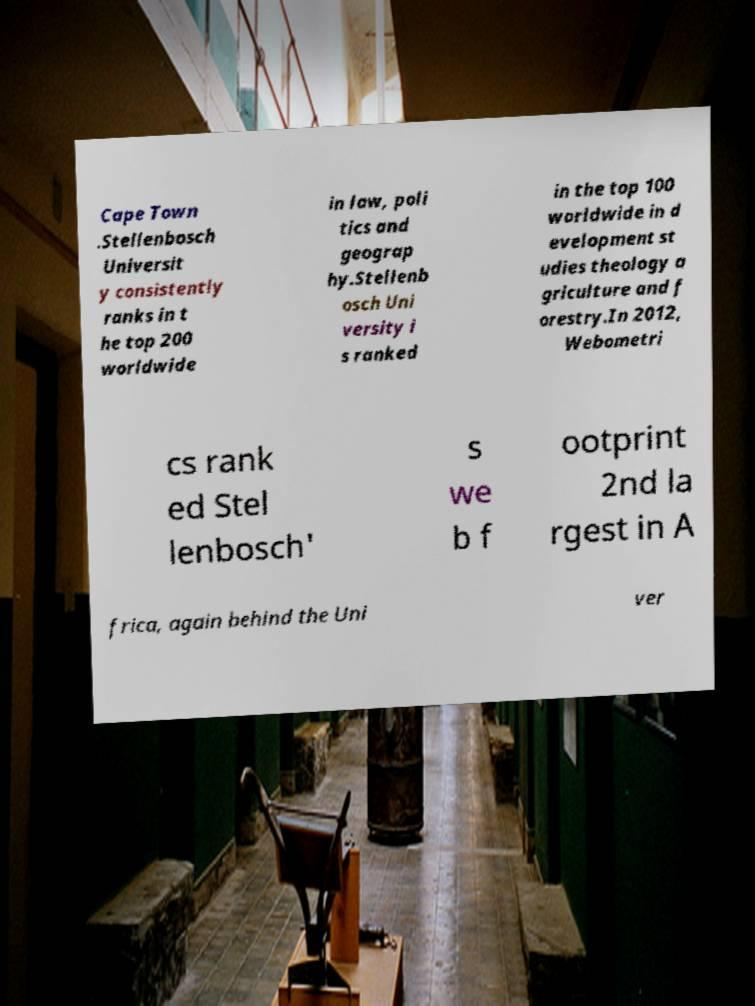Please identify and transcribe the text found in this image. Cape Town .Stellenbosch Universit y consistently ranks in t he top 200 worldwide in law, poli tics and geograp hy.Stellenb osch Uni versity i s ranked in the top 100 worldwide in d evelopment st udies theology a griculture and f orestry.In 2012, Webometri cs rank ed Stel lenbosch' s we b f ootprint 2nd la rgest in A frica, again behind the Uni ver 